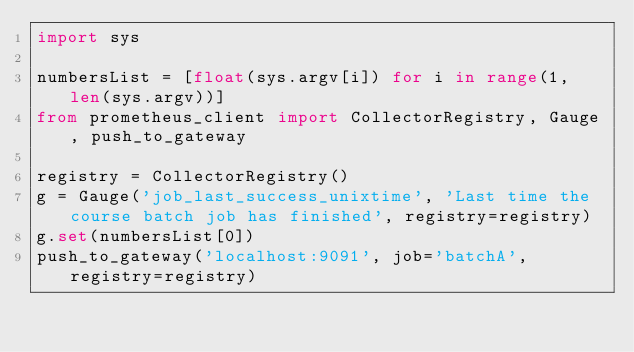Convert code to text. <code><loc_0><loc_0><loc_500><loc_500><_Python_>import sys

numbersList = [float(sys.argv[i]) for i in range(1, len(sys.argv))]
from prometheus_client import CollectorRegistry, Gauge, push_to_gateway

registry = CollectorRegistry()
g = Gauge('job_last_success_unixtime', 'Last time the course batch job has finished', registry=registry)
g.set(numbersList[0])
push_to_gateway('localhost:9091', job='batchA', registry=registry)
</code> 